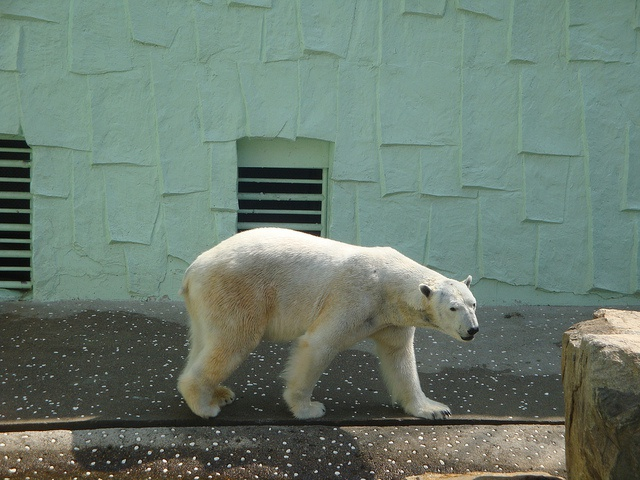Describe the objects in this image and their specific colors. I can see a bear in teal, gray, darkgray, and ivory tones in this image. 